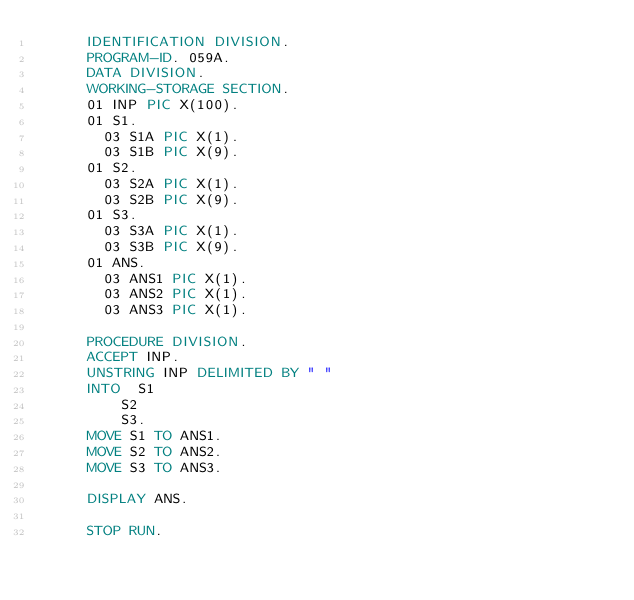<code> <loc_0><loc_0><loc_500><loc_500><_COBOL_>      IDENTIFICATION DIVISION.
      PROGRAM-ID. 059A.
      DATA DIVISION.
      WORKING-STORAGE SECTION.
      01 INP PIC X(100).
      01 S1.
        03 S1A PIC X(1).
      	03 S1B PIC X(9).
      01 S2.
        03 S2A PIC X(1).
      	03 S2B PIC X(9).
      01 S3.
        03 S3A PIC X(1).
      	03 S3B PIC X(9).
      01 ANS.
        03 ANS1 PIC X(1).
        03 ANS2 PIC X(1).
        03 ANS3 PIC X(1).
            
      PROCEDURE DIVISION.
      ACCEPT INP.
      UNSTRING INP DELIMITED BY " "
      INTO 	S1
      		S2
      		S3.
      MOVE S1 TO ANS1.
      MOVE S2 TO ANS2.
      MOVE S3 TO ANS3.
      
      DISPLAY ANS.
      
      STOP RUN.</code> 